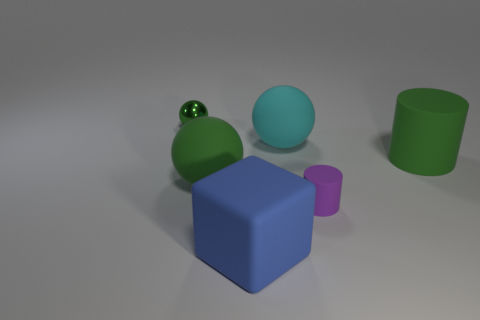What is the color of the large rubber cylinder?
Offer a terse response. Green. Do the blue cube and the green cylinder have the same size?
Give a very brief answer. Yes. Is there any other thing that has the same shape as the cyan matte thing?
Keep it short and to the point. Yes. Do the block and the green thing to the right of the small cylinder have the same material?
Keep it short and to the point. Yes. Do the thing that is behind the cyan rubber object and the large block have the same color?
Provide a succinct answer. No. How many rubber things are left of the cyan matte ball and behind the big blue object?
Your answer should be very brief. 1. What number of other things are there of the same material as the small sphere
Your response must be concise. 0. Do the object that is in front of the purple rubber object and the big cylinder have the same material?
Offer a terse response. Yes. What is the size of the ball that is in front of the green rubber object that is to the right of the green ball that is on the right side of the tiny metallic object?
Offer a very short reply. Large. What number of other objects are the same color as the small shiny object?
Your answer should be compact. 2. 